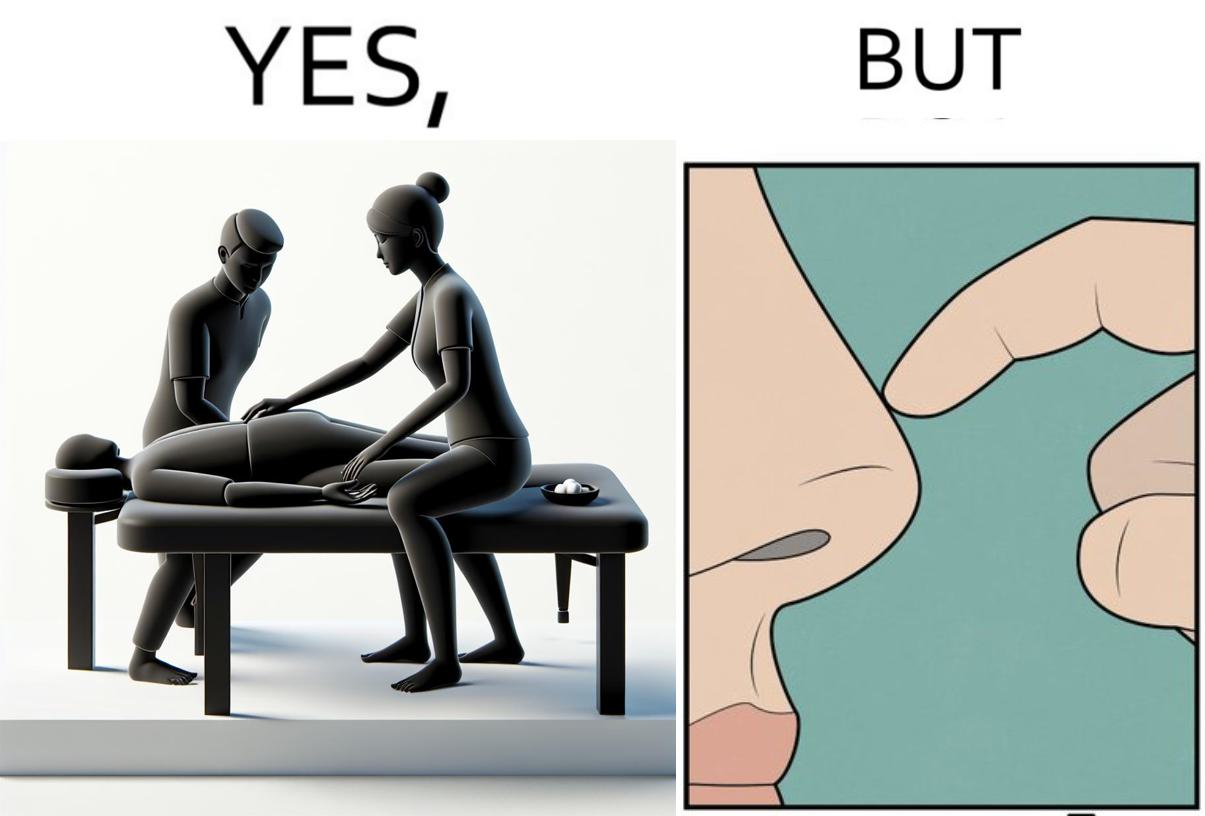What is shown in this image? This is a satirical image with contrasting elements. 